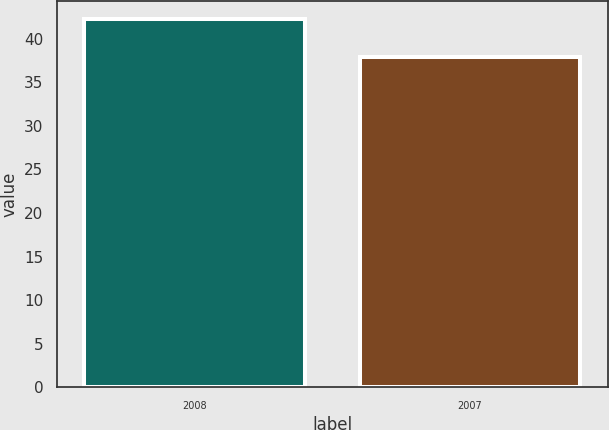Convert chart. <chart><loc_0><loc_0><loc_500><loc_500><bar_chart><fcel>2008<fcel>2007<nl><fcel>42.26<fcel>37.87<nl></chart> 